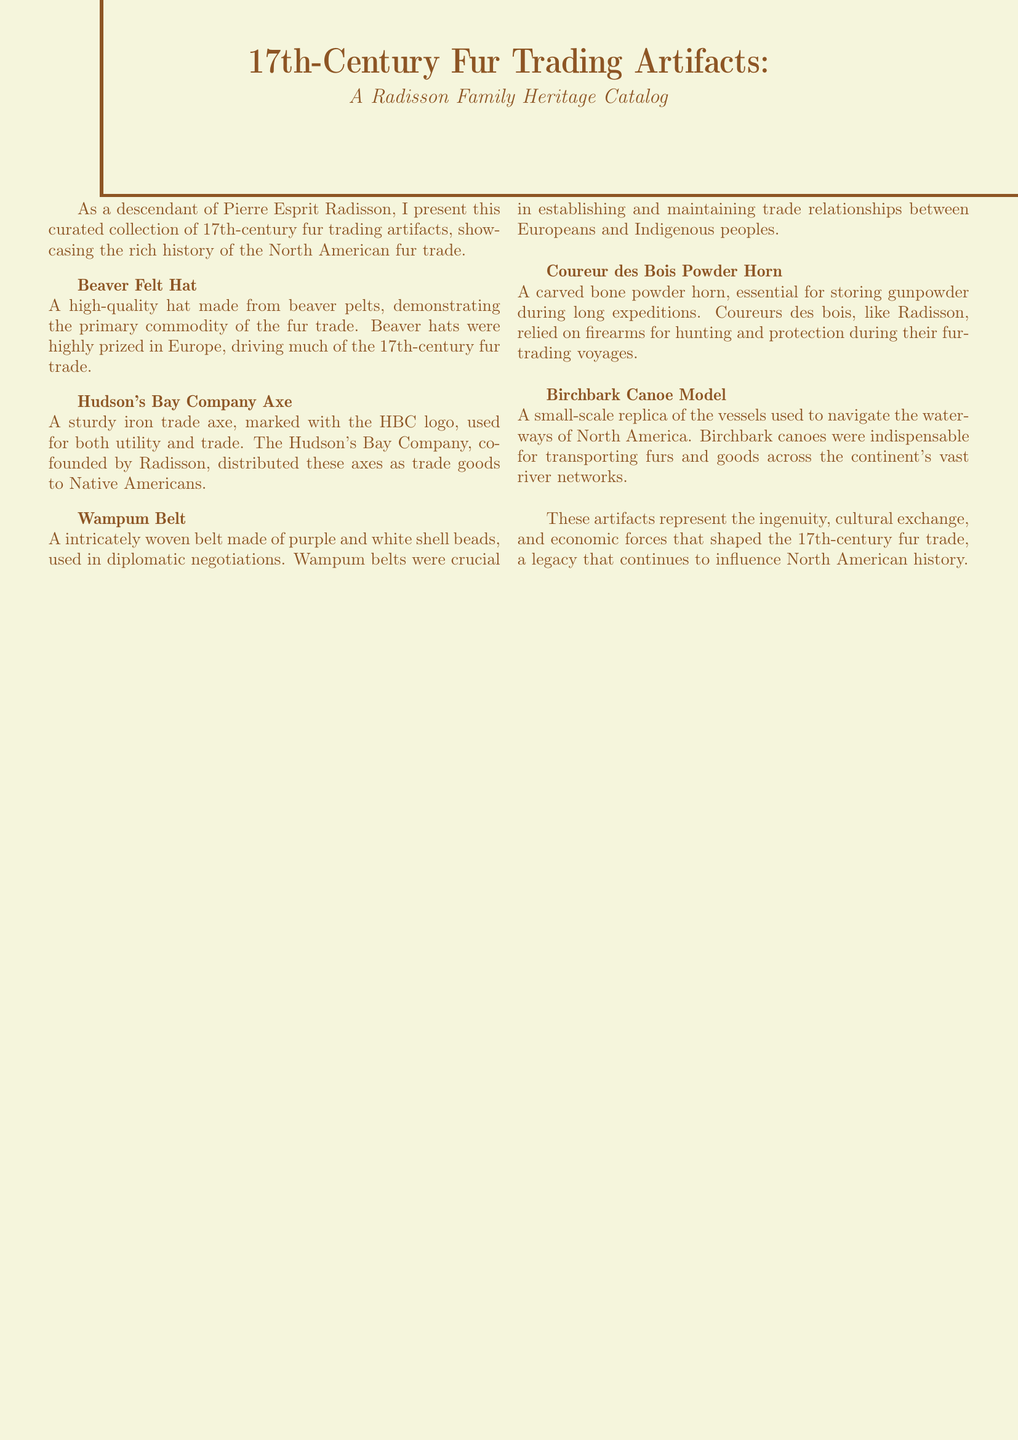What is the title of the catalog? The title of the catalog is presented prominently at the beginning of the document.
Answer: 17th-Century Fur Trading Artifacts: A Radisson Family Heritage Catalog Who is the catalog curated by? The curator of the catalog is mentioned in the introductory section of the document.
Answer: A descendant of Pierre Esprit Radisson What type of hat is featured in the catalog? The document specifically names this type of hat as a significant artifact of the fur trade.
Answer: Beaver Felt Hat What artifact is used for both utility and trade? The document describes this artifact's dual purpose, marking its significance in the fur trade.
Answer: Hudson's Bay Company Axe What material is the Wampum Belt made from? The document details the composition of the Wampum Belt artifact.
Answer: Shell beads Which artifact was essential for storing gunpowder? The catalog specifies the function of this artifact for traders during expeditions.
Answer: Coureur des Bois Powder Horn How were birchbark canoes significant in the fur trade? The document provides insight into the utility of this vessel in the context of trading.
Answer: Transporting furs and goods What color scheme is the document primarily using? The document's colors and aesthetics are integral to its presentation.
Answer: Russet and Beige 